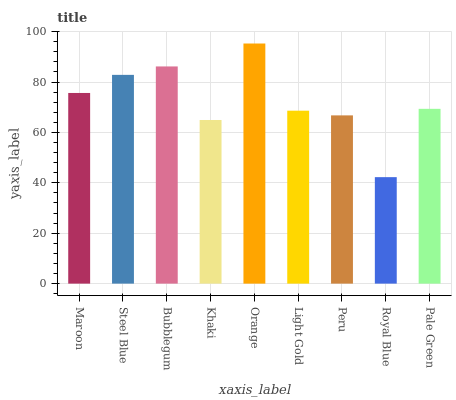Is Royal Blue the minimum?
Answer yes or no. Yes. Is Orange the maximum?
Answer yes or no. Yes. Is Steel Blue the minimum?
Answer yes or no. No. Is Steel Blue the maximum?
Answer yes or no. No. Is Steel Blue greater than Maroon?
Answer yes or no. Yes. Is Maroon less than Steel Blue?
Answer yes or no. Yes. Is Maroon greater than Steel Blue?
Answer yes or no. No. Is Steel Blue less than Maroon?
Answer yes or no. No. Is Pale Green the high median?
Answer yes or no. Yes. Is Pale Green the low median?
Answer yes or no. Yes. Is Steel Blue the high median?
Answer yes or no. No. Is Peru the low median?
Answer yes or no. No. 